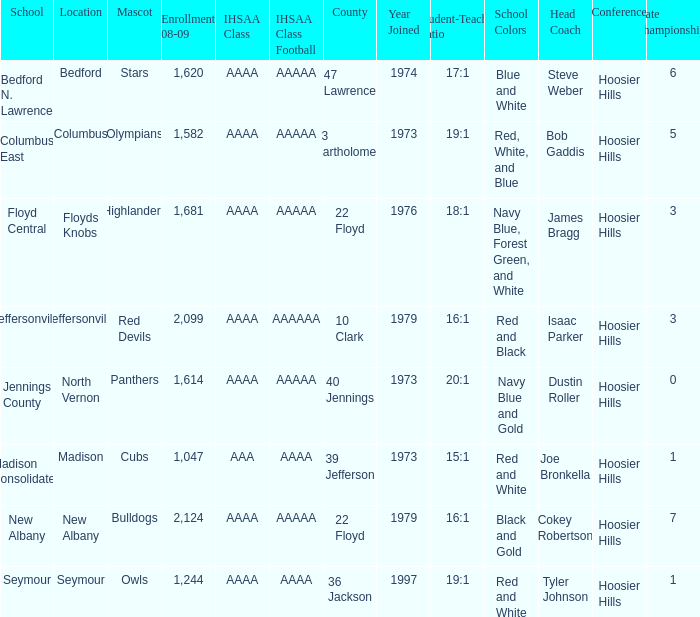If panthers are the mascot, which ihsaa class football does it represent? AAAAA. 